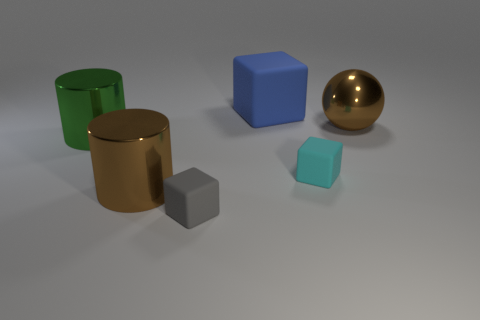Are there more big green things than large purple shiny cubes?
Provide a short and direct response. Yes. How many other things are there of the same shape as the tiny cyan matte object?
Provide a short and direct response. 2. Is the color of the large sphere the same as the large matte cube?
Your answer should be compact. No. What material is the big object that is right of the brown cylinder and left of the large brown sphere?
Ensure brevity in your answer.  Rubber. How big is the brown shiny sphere?
Keep it short and to the point. Large. How many gray matte things are on the right side of the small rubber cube behind the large brown thing left of the cyan thing?
Offer a very short reply. 0. What is the shape of the brown thing to the right of the large brown metallic thing that is on the left side of the brown sphere?
Keep it short and to the point. Sphere. The brown object that is the same shape as the green shiny thing is what size?
Offer a very short reply. Large. Are there any other things that have the same size as the brown shiny sphere?
Your response must be concise. Yes. What color is the tiny matte block left of the blue block?
Ensure brevity in your answer.  Gray. 